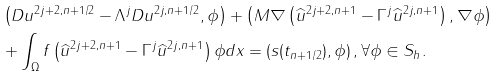<formula> <loc_0><loc_0><loc_500><loc_500>& \left ( D u ^ { 2 j + 2 , n + 1 / 2 } - \Lambda ^ { j } D u ^ { 2 j , n + 1 / 2 } , \phi \right ) + \left ( M \nabla \left ( \widehat { u } ^ { 2 j + 2 , n + 1 } - \Gamma ^ { j } \widehat { u } ^ { 2 j , n + 1 } \right ) , \nabla \phi \right ) \\ & + \int _ { \Omega } f \left ( \widehat { u } ^ { 2 j + 2 , n + 1 } - \Gamma ^ { j } \widehat { u } ^ { 2 j , n + 1 } \right ) \phi d x = \left ( s ( t _ { n + 1 / 2 } ) , \phi \right ) , \forall \phi \in S _ { h } .</formula> 